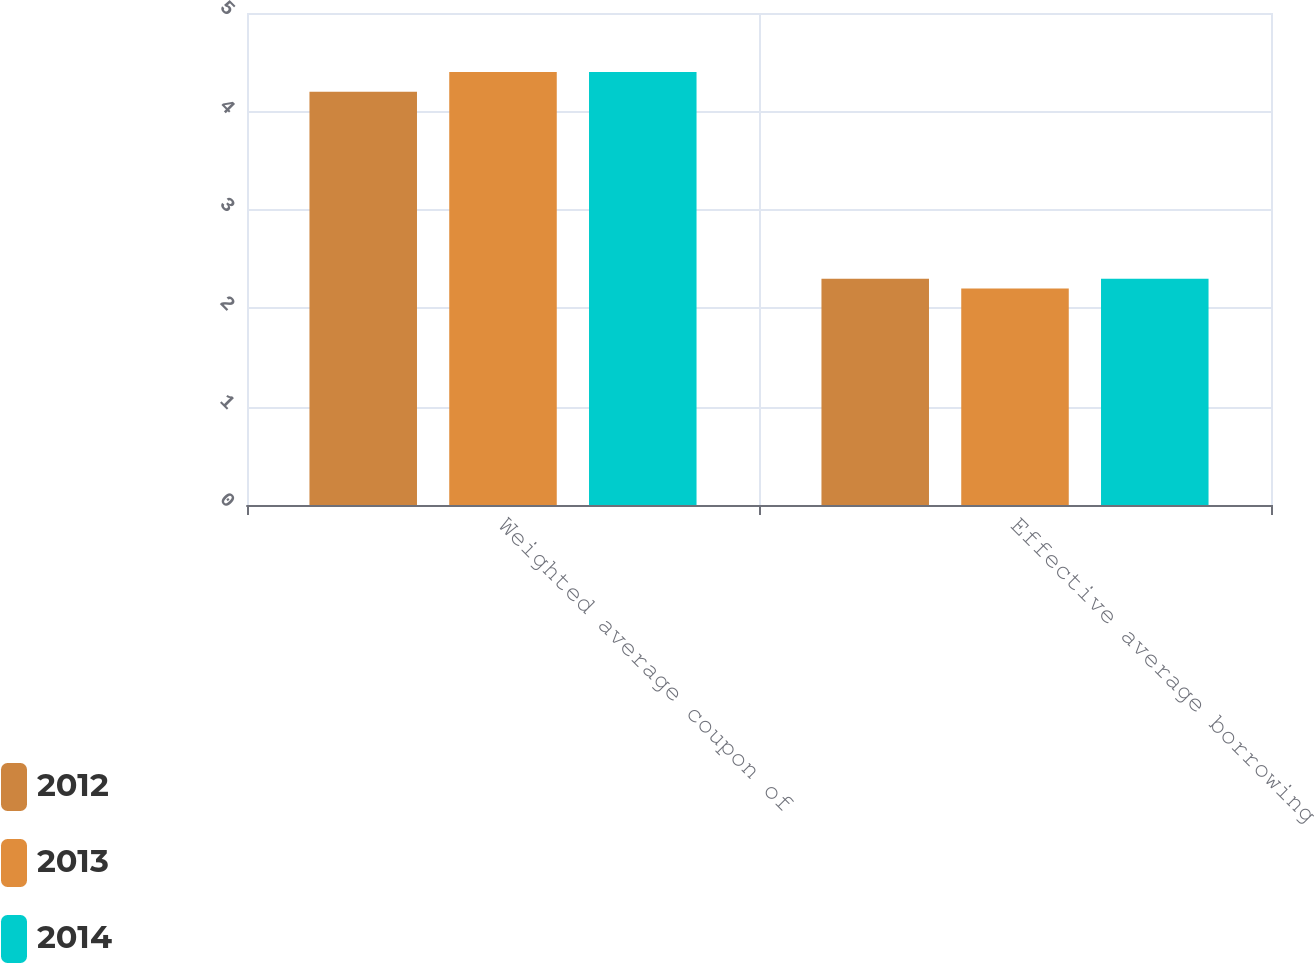Convert chart to OTSL. <chart><loc_0><loc_0><loc_500><loc_500><stacked_bar_chart><ecel><fcel>Weighted average coupon of<fcel>Effective average borrowing<nl><fcel>2012<fcel>4.2<fcel>2.3<nl><fcel>2013<fcel>4.4<fcel>2.2<nl><fcel>2014<fcel>4.4<fcel>2.3<nl></chart> 